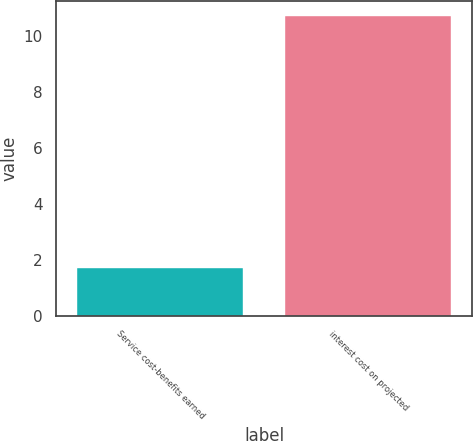<chart> <loc_0><loc_0><loc_500><loc_500><bar_chart><fcel>Service cost-benefits earned<fcel>interest cost on projected<nl><fcel>1.7<fcel>10.7<nl></chart> 